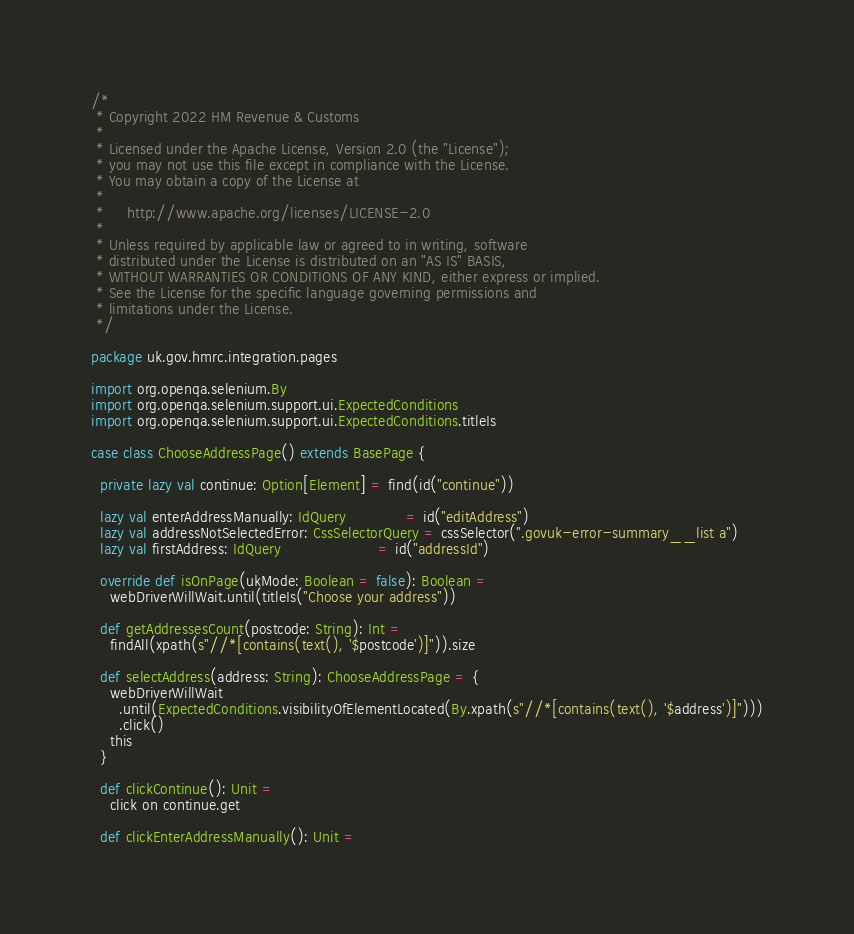<code> <loc_0><loc_0><loc_500><loc_500><_Scala_>/*
 * Copyright 2022 HM Revenue & Customs
 *
 * Licensed under the Apache License, Version 2.0 (the "License");
 * you may not use this file except in compliance with the License.
 * You may obtain a copy of the License at
 *
 *     http://www.apache.org/licenses/LICENSE-2.0
 *
 * Unless required by applicable law or agreed to in writing, software
 * distributed under the License is distributed on an "AS IS" BASIS,
 * WITHOUT WARRANTIES OR CONDITIONS OF ANY KIND, either express or implied.
 * See the License for the specific language governing permissions and
 * limitations under the License.
 */

package uk.gov.hmrc.integration.pages

import org.openqa.selenium.By
import org.openqa.selenium.support.ui.ExpectedConditions
import org.openqa.selenium.support.ui.ExpectedConditions.titleIs

case class ChooseAddressPage() extends BasePage {

  private lazy val continue: Option[Element] = find(id("continue"))

  lazy val enterAddressManually: IdQuery             = id("editAddress")
  lazy val addressNotSelectedError: CssSelectorQuery = cssSelector(".govuk-error-summary__list a")
  lazy val firstAddress: IdQuery                     = id("addressId")

  override def isOnPage(ukMode: Boolean = false): Boolean =
    webDriverWillWait.until(titleIs("Choose your address"))

  def getAddressesCount(postcode: String): Int =
    findAll(xpath(s"//*[contains(text(), '$postcode')]")).size

  def selectAddress(address: String): ChooseAddressPage = {
    webDriverWillWait
      .until(ExpectedConditions.visibilityOfElementLocated(By.xpath(s"//*[contains(text(), '$address')]")))
      .click()
    this
  }

  def clickContinue(): Unit =
    click on continue.get

  def clickEnterAddressManually(): Unit =</code> 